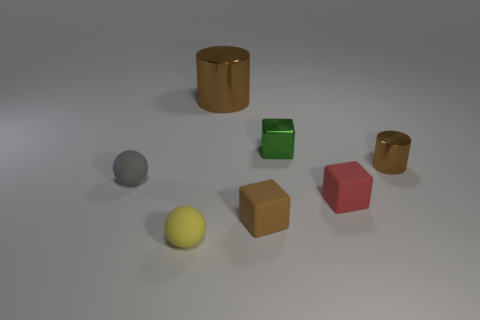Add 2 cyan things. How many objects exist? 9 Subtract all cubes. How many objects are left? 4 Subtract 1 green blocks. How many objects are left? 6 Subtract all purple matte objects. Subtract all gray matte things. How many objects are left? 6 Add 2 green shiny objects. How many green shiny objects are left? 3 Add 1 small cyan matte cubes. How many small cyan matte cubes exist? 1 